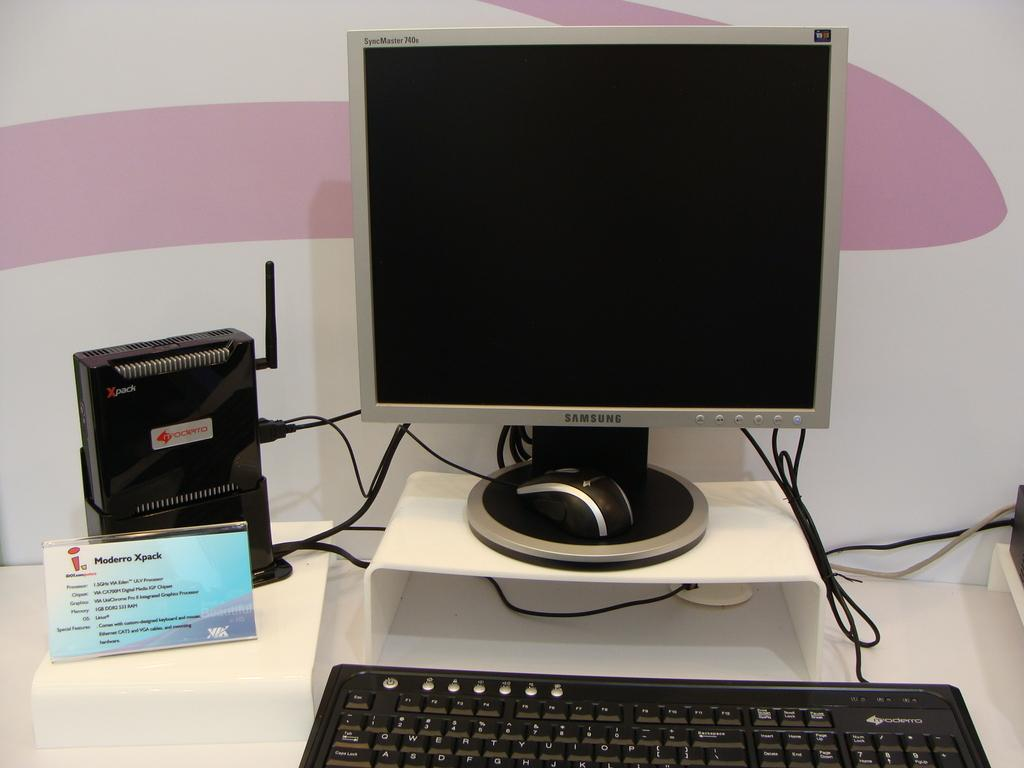<image>
Relay a brief, clear account of the picture shown. The Moderro Xpack display showing  a Samsung monitor, Moderro tower and keyboard. 